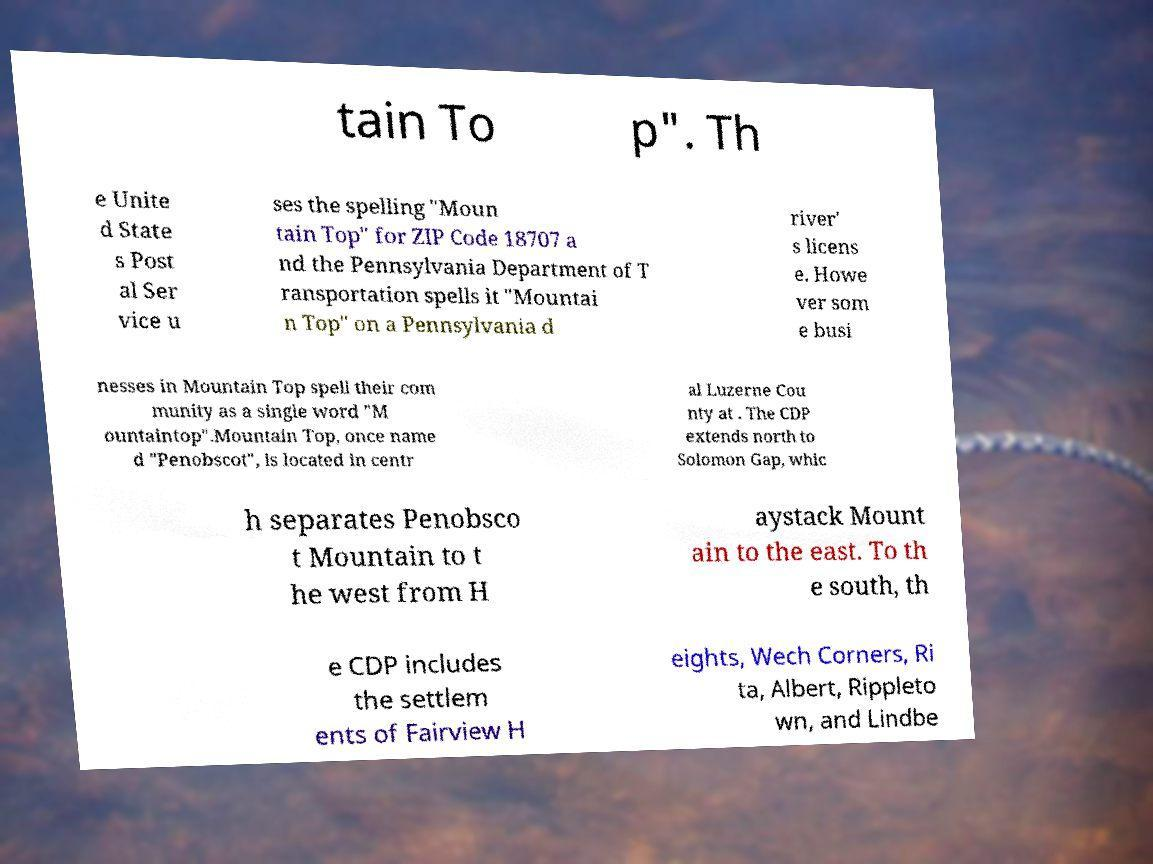For documentation purposes, I need the text within this image transcribed. Could you provide that? tain To p". Th e Unite d State s Post al Ser vice u ses the spelling "Moun tain Top" for ZIP Code 18707 a nd the Pennsylvania Department of T ransportation spells it "Mountai n Top" on a Pennsylvania d river' s licens e. Howe ver som e busi nesses in Mountain Top spell their com munity as a single word "M ountaintop".Mountain Top, once name d "Penobscot", is located in centr al Luzerne Cou nty at . The CDP extends north to Solomon Gap, whic h separates Penobsco t Mountain to t he west from H aystack Mount ain to the east. To th e south, th e CDP includes the settlem ents of Fairview H eights, Wech Corners, Ri ta, Albert, Rippleto wn, and Lindbe 